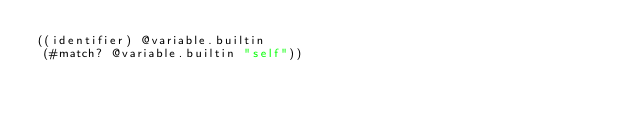<code> <loc_0><loc_0><loc_500><loc_500><_Scheme_>((identifier) @variable.builtin
 (#match? @variable.builtin "self"))
</code> 